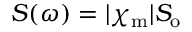Convert formula to latex. <formula><loc_0><loc_0><loc_500><loc_500>S ( \omega ) = | \chi _ { m } | S _ { o }</formula> 